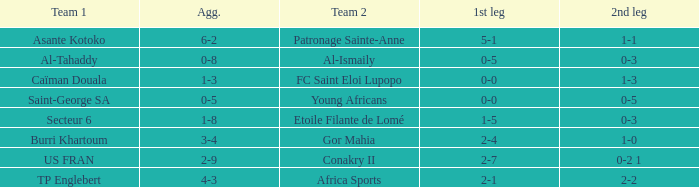Which team lost 0-3 and 0-5? Al-Tahaddy. 